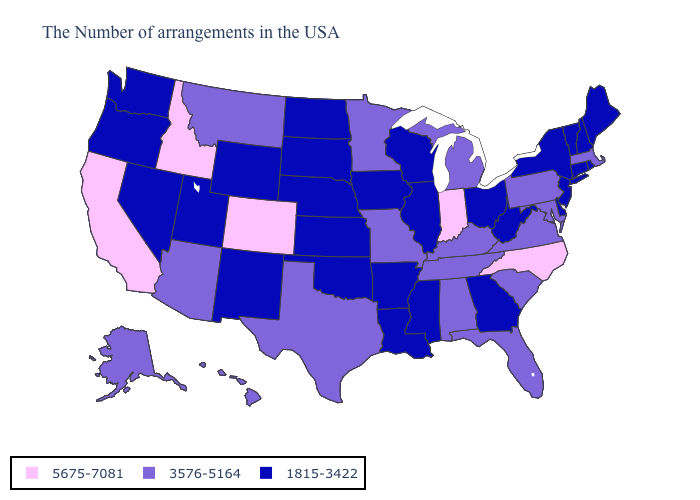Among the states that border Oklahoma , which have the highest value?
Answer briefly. Colorado. What is the highest value in states that border Oregon?
Answer briefly. 5675-7081. Which states have the lowest value in the Northeast?
Answer briefly. Maine, Rhode Island, New Hampshire, Vermont, Connecticut, New York, New Jersey. Does the map have missing data?
Be succinct. No. What is the lowest value in the USA?
Be succinct. 1815-3422. Name the states that have a value in the range 5675-7081?
Give a very brief answer. North Carolina, Indiana, Colorado, Idaho, California. What is the lowest value in the USA?
Quick response, please. 1815-3422. What is the lowest value in the USA?
Concise answer only. 1815-3422. What is the value of California?
Write a very short answer. 5675-7081. Is the legend a continuous bar?
Write a very short answer. No. Does New Jersey have the highest value in the USA?
Concise answer only. No. Which states have the lowest value in the Northeast?
Quick response, please. Maine, Rhode Island, New Hampshire, Vermont, Connecticut, New York, New Jersey. Among the states that border South Carolina , which have the highest value?
Quick response, please. North Carolina. What is the highest value in states that border New York?
Short answer required. 3576-5164. Does Michigan have the lowest value in the USA?
Concise answer only. No. 